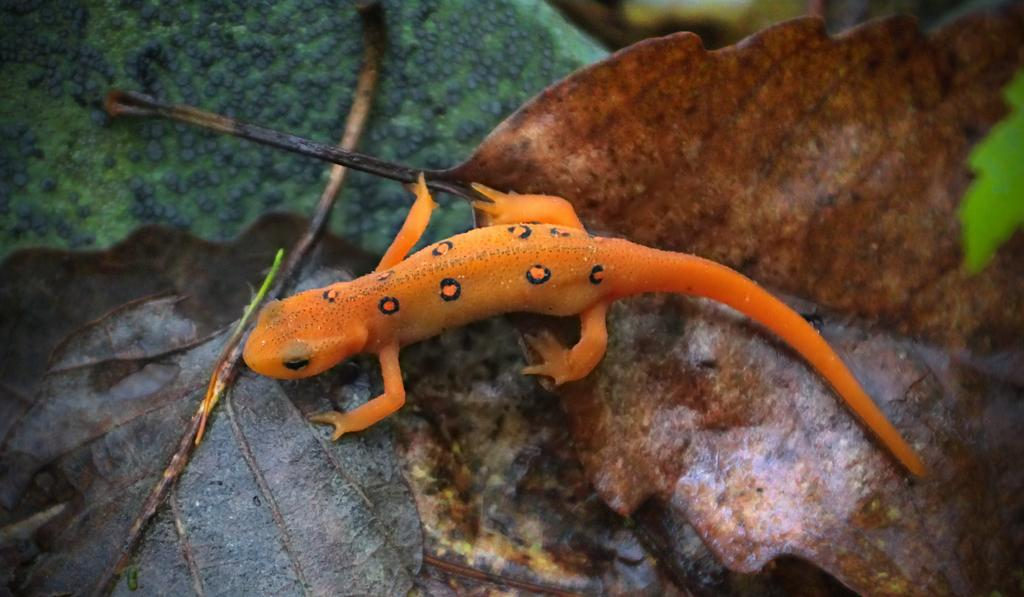What type of animal is in the image? There is a lizard in the image. What is the lizard resting on? The lizard is on some dried leaves. What color is the green object in the image? The green object in the image is not described in the facts provided. What type of event is happening in the image? There is no event happening in the image; it simply shows a lizard on some dried leaves. What type of beast is present in the image? The only animal mentioned in the image is a lizard, which is not considered a beast. 